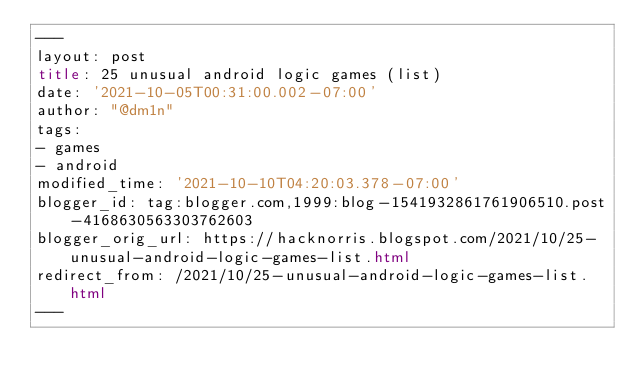<code> <loc_0><loc_0><loc_500><loc_500><_HTML_>---
layout: post
title: 25 unusual android logic games (list)
date: '2021-10-05T00:31:00.002-07:00'
author: "@dm1n"
tags:
- games
- android
modified_time: '2021-10-10T04:20:03.378-07:00'
blogger_id: tag:blogger.com,1999:blog-1541932861761906510.post-4168630563303762603
blogger_orig_url: https://hacknorris.blogspot.com/2021/10/25-unusual-android-logic-games-list.html
redirect_from: /2021/10/25-unusual-android-logic-games-list.html
---
</code> 